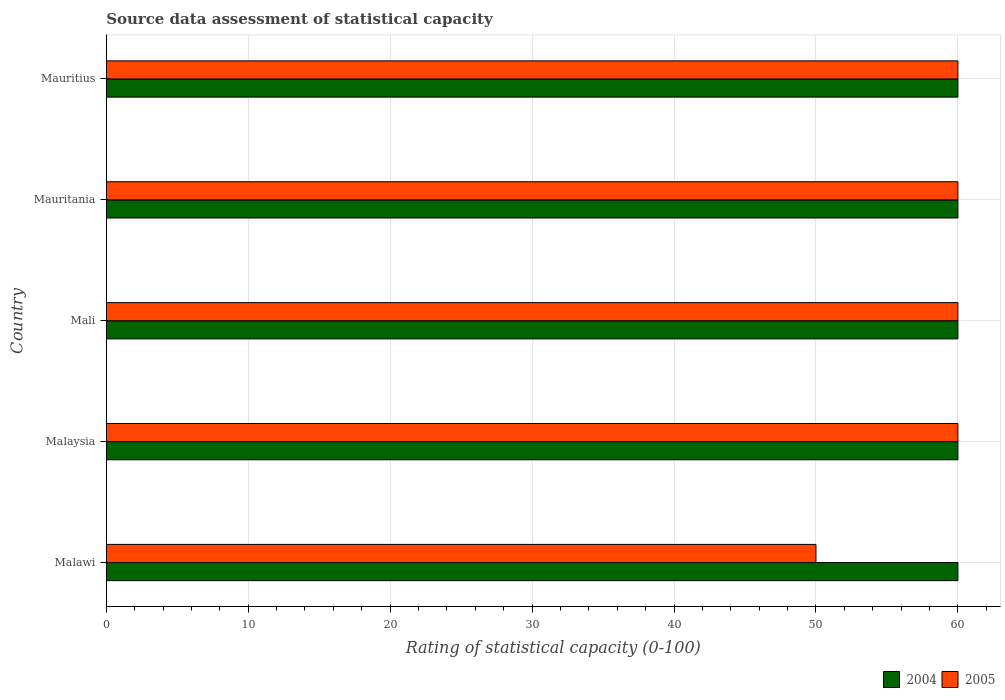How many different coloured bars are there?
Provide a succinct answer. 2. How many groups of bars are there?
Provide a short and direct response. 5. Are the number of bars per tick equal to the number of legend labels?
Offer a terse response. Yes. How many bars are there on the 1st tick from the top?
Provide a short and direct response. 2. How many bars are there on the 4th tick from the bottom?
Offer a terse response. 2. What is the label of the 4th group of bars from the top?
Your answer should be very brief. Malaysia. Across all countries, what is the maximum rating of statistical capacity in 2004?
Your answer should be compact. 60. Across all countries, what is the minimum rating of statistical capacity in 2004?
Your response must be concise. 60. In which country was the rating of statistical capacity in 2005 maximum?
Offer a terse response. Malaysia. In which country was the rating of statistical capacity in 2005 minimum?
Make the answer very short. Malawi. What is the total rating of statistical capacity in 2004 in the graph?
Your response must be concise. 300. What is the difference between the rating of statistical capacity in 2005 in Mali and that in Mauritius?
Give a very brief answer. 0. What is the difference between the rating of statistical capacity in 2005 in Mauritius and the rating of statistical capacity in 2004 in Malawi?
Your answer should be very brief. 0. What is the difference between the rating of statistical capacity in 2004 and rating of statistical capacity in 2005 in Mali?
Offer a terse response. 0. What is the ratio of the rating of statistical capacity in 2005 in Malawi to that in Mauritius?
Offer a terse response. 0.83. Is the rating of statistical capacity in 2004 in Malawi less than that in Mali?
Provide a succinct answer. No. Is the difference between the rating of statistical capacity in 2004 in Malaysia and Mali greater than the difference between the rating of statistical capacity in 2005 in Malaysia and Mali?
Give a very brief answer. No. What is the difference between the highest and the second highest rating of statistical capacity in 2005?
Make the answer very short. 0. What is the difference between the highest and the lowest rating of statistical capacity in 2004?
Offer a terse response. 0. In how many countries, is the rating of statistical capacity in 2004 greater than the average rating of statistical capacity in 2004 taken over all countries?
Provide a succinct answer. 0. Is the sum of the rating of statistical capacity in 2004 in Mali and Mauritania greater than the maximum rating of statistical capacity in 2005 across all countries?
Keep it short and to the point. Yes. How many bars are there?
Give a very brief answer. 10. Are all the bars in the graph horizontal?
Offer a very short reply. Yes. Are the values on the major ticks of X-axis written in scientific E-notation?
Provide a succinct answer. No. Does the graph contain grids?
Provide a succinct answer. Yes. Where does the legend appear in the graph?
Ensure brevity in your answer.  Bottom right. How many legend labels are there?
Keep it short and to the point. 2. How are the legend labels stacked?
Give a very brief answer. Horizontal. What is the title of the graph?
Ensure brevity in your answer.  Source data assessment of statistical capacity. Does "1963" appear as one of the legend labels in the graph?
Ensure brevity in your answer.  No. What is the label or title of the X-axis?
Ensure brevity in your answer.  Rating of statistical capacity (0-100). What is the Rating of statistical capacity (0-100) in 2004 in Malaysia?
Your response must be concise. 60. What is the Rating of statistical capacity (0-100) of 2005 in Mali?
Offer a very short reply. 60. What is the Rating of statistical capacity (0-100) in 2004 in Mauritania?
Provide a succinct answer. 60. What is the Rating of statistical capacity (0-100) in 2005 in Mauritania?
Provide a short and direct response. 60. What is the Rating of statistical capacity (0-100) of 2004 in Mauritius?
Your answer should be very brief. 60. What is the Rating of statistical capacity (0-100) of 2005 in Mauritius?
Keep it short and to the point. 60. Across all countries, what is the maximum Rating of statistical capacity (0-100) of 2004?
Provide a succinct answer. 60. Across all countries, what is the maximum Rating of statistical capacity (0-100) in 2005?
Keep it short and to the point. 60. Across all countries, what is the minimum Rating of statistical capacity (0-100) of 2005?
Offer a terse response. 50. What is the total Rating of statistical capacity (0-100) in 2004 in the graph?
Your answer should be compact. 300. What is the total Rating of statistical capacity (0-100) of 2005 in the graph?
Your answer should be very brief. 290. What is the difference between the Rating of statistical capacity (0-100) of 2004 in Malawi and that in Malaysia?
Ensure brevity in your answer.  0. What is the difference between the Rating of statistical capacity (0-100) of 2005 in Malawi and that in Malaysia?
Offer a terse response. -10. What is the difference between the Rating of statistical capacity (0-100) of 2005 in Malawi and that in Mali?
Make the answer very short. -10. What is the difference between the Rating of statistical capacity (0-100) in 2005 in Malawi and that in Mauritania?
Keep it short and to the point. -10. What is the difference between the Rating of statistical capacity (0-100) of 2004 in Malawi and that in Mauritius?
Provide a short and direct response. 0. What is the difference between the Rating of statistical capacity (0-100) in 2005 in Malawi and that in Mauritius?
Provide a succinct answer. -10. What is the difference between the Rating of statistical capacity (0-100) in 2004 in Malaysia and that in Mali?
Provide a short and direct response. 0. What is the difference between the Rating of statistical capacity (0-100) of 2005 in Malaysia and that in Mauritania?
Offer a terse response. 0. What is the difference between the Rating of statistical capacity (0-100) in 2004 in Malaysia and that in Mauritius?
Provide a succinct answer. 0. What is the difference between the Rating of statistical capacity (0-100) in 2005 in Malaysia and that in Mauritius?
Keep it short and to the point. 0. What is the difference between the Rating of statistical capacity (0-100) in 2004 in Mali and that in Mauritania?
Keep it short and to the point. 0. What is the difference between the Rating of statistical capacity (0-100) of 2004 in Mali and that in Mauritius?
Offer a terse response. 0. What is the difference between the Rating of statistical capacity (0-100) in 2005 in Mali and that in Mauritius?
Your answer should be compact. 0. What is the difference between the Rating of statistical capacity (0-100) of 2004 in Mauritania and that in Mauritius?
Ensure brevity in your answer.  0. What is the difference between the Rating of statistical capacity (0-100) in 2004 in Malawi and the Rating of statistical capacity (0-100) in 2005 in Mauritania?
Make the answer very short. 0. What is the difference between the Rating of statistical capacity (0-100) in 2004 in Malawi and the Rating of statistical capacity (0-100) in 2005 in Mauritius?
Give a very brief answer. 0. What is the difference between the Rating of statistical capacity (0-100) of 2004 in Malaysia and the Rating of statistical capacity (0-100) of 2005 in Mauritania?
Your response must be concise. 0. What is the difference between the Rating of statistical capacity (0-100) of 2004 in Mauritania and the Rating of statistical capacity (0-100) of 2005 in Mauritius?
Offer a terse response. 0. What is the average Rating of statistical capacity (0-100) of 2004 per country?
Ensure brevity in your answer.  60. What is the average Rating of statistical capacity (0-100) of 2005 per country?
Offer a very short reply. 58. What is the ratio of the Rating of statistical capacity (0-100) in 2004 in Malawi to that in Malaysia?
Your response must be concise. 1. What is the ratio of the Rating of statistical capacity (0-100) of 2005 in Malawi to that in Malaysia?
Your response must be concise. 0.83. What is the ratio of the Rating of statistical capacity (0-100) of 2004 in Malawi to that in Mali?
Your response must be concise. 1. What is the ratio of the Rating of statistical capacity (0-100) in 2004 in Malawi to that in Mauritania?
Give a very brief answer. 1. What is the ratio of the Rating of statistical capacity (0-100) in 2004 in Malawi to that in Mauritius?
Make the answer very short. 1. What is the ratio of the Rating of statistical capacity (0-100) in 2005 in Malawi to that in Mauritius?
Your response must be concise. 0.83. What is the ratio of the Rating of statistical capacity (0-100) in 2004 in Malaysia to that in Mali?
Your answer should be compact. 1. What is the ratio of the Rating of statistical capacity (0-100) of 2004 in Malaysia to that in Mauritius?
Make the answer very short. 1. What is the ratio of the Rating of statistical capacity (0-100) in 2004 in Mali to that in Mauritania?
Provide a short and direct response. 1. What is the ratio of the Rating of statistical capacity (0-100) of 2005 in Mauritania to that in Mauritius?
Your answer should be very brief. 1. 